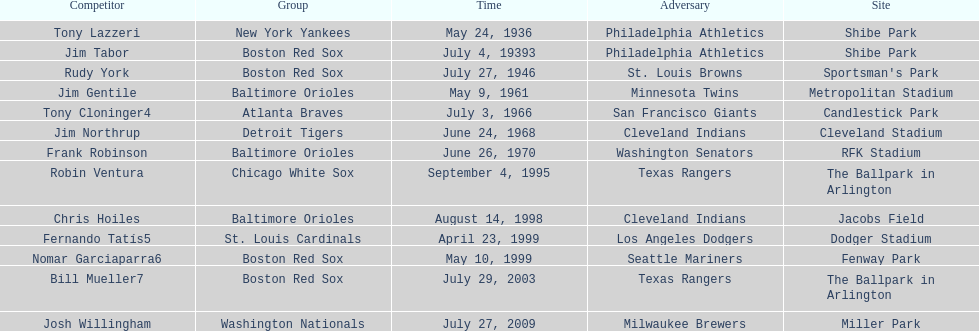Who is the first major league hitter to hit two grand slams in one game? Tony Lazzeri. 